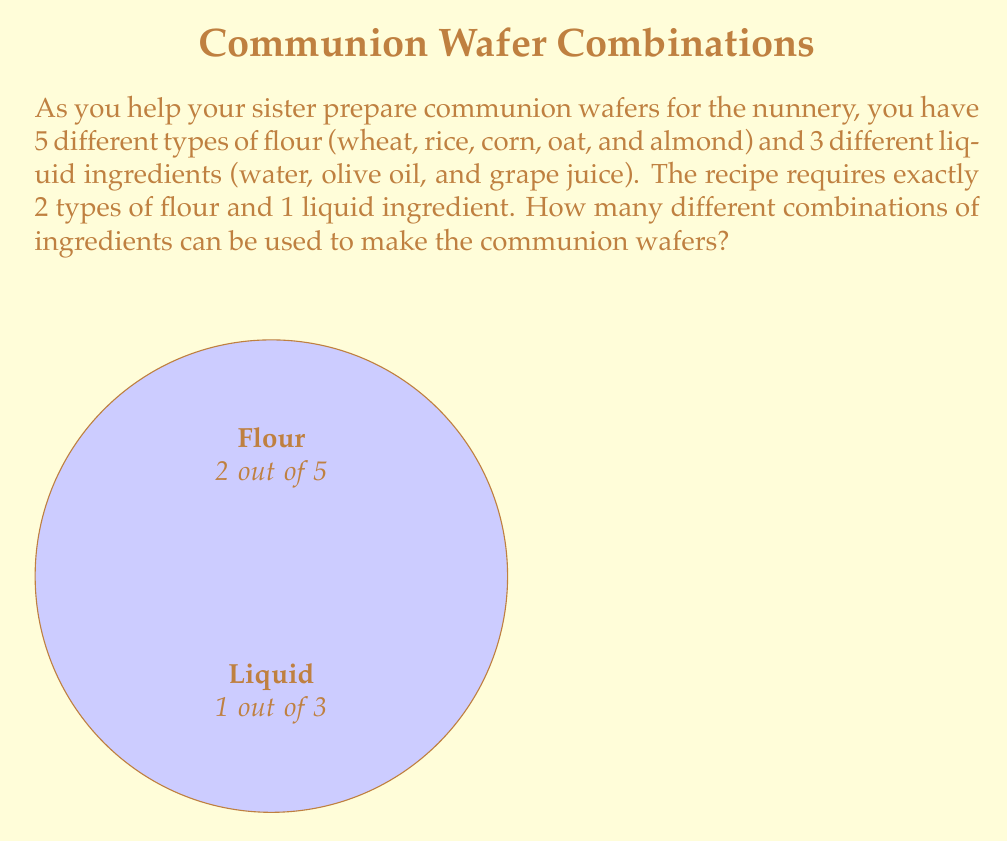Provide a solution to this math problem. Let's break this down step-by-step:

1) First, we need to calculate how many ways we can choose 2 types of flour out of 5. This is a combination problem, denoted as $\binom{5}{2}$ or $C(5,2)$.

   $$\binom{5}{2} = \frac{5!}{2!(5-2)!} = \frac{5!}{2!3!} = \frac{5 \cdot 4}{2 \cdot 1} = 10$$

2) Next, we need to consider the liquid ingredient. We're simply choosing 1 out of 3, which is just 3 choices.

3) Now, for each way of choosing the flour, we have 3 choices for the liquid. This is a multiplication principle scenario.

4) Therefore, the total number of combinations is:

   $$10 \cdot 3 = 30$$

Thus, there are 30 different possible combinations of ingredients for making the communion wafers.
Answer: 30 combinations 